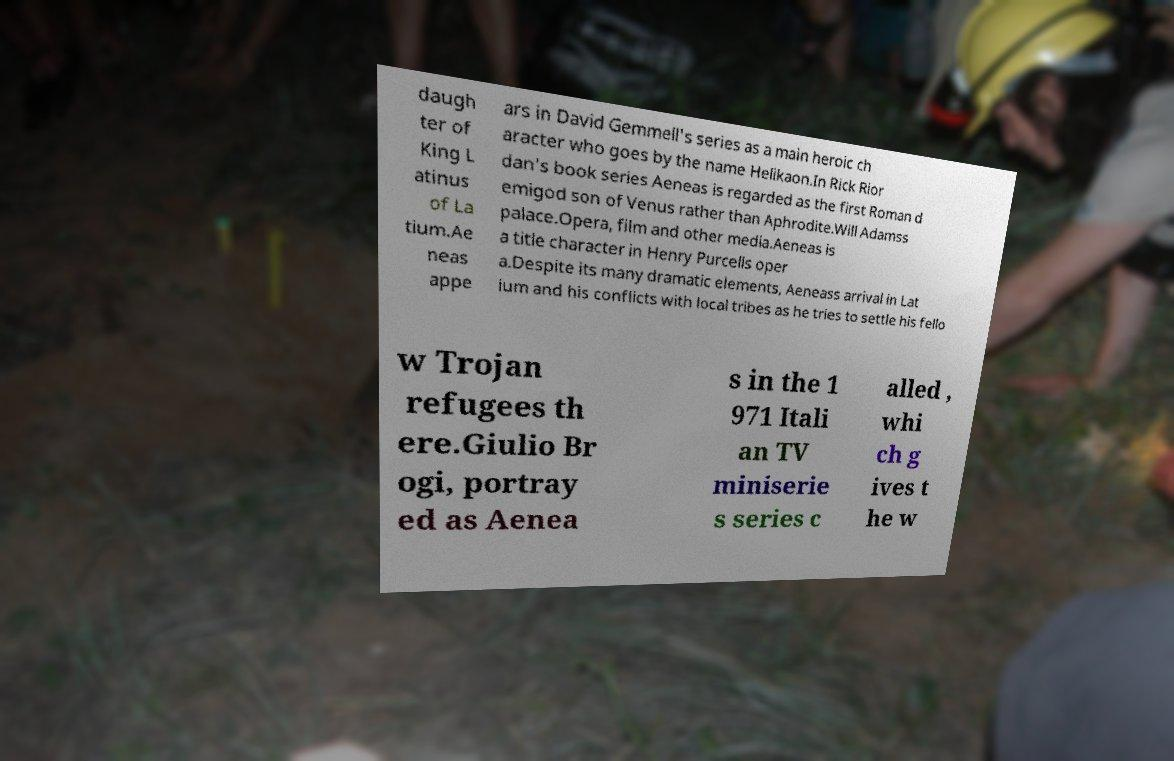Could you extract and type out the text from this image? daugh ter of King L atinus of La tium.Ae neas appe ars in David Gemmell's series as a main heroic ch aracter who goes by the name Helikaon.In Rick Rior dan's book series Aeneas is regarded as the first Roman d emigod son of Venus rather than Aphrodite.Will Adamss palace.Opera, film and other media.Aeneas is a title character in Henry Purcells oper a.Despite its many dramatic elements, Aeneass arrival in Lat ium and his conflicts with local tribes as he tries to settle his fello w Trojan refugees th ere.Giulio Br ogi, portray ed as Aenea s in the 1 971 Itali an TV miniserie s series c alled , whi ch g ives t he w 